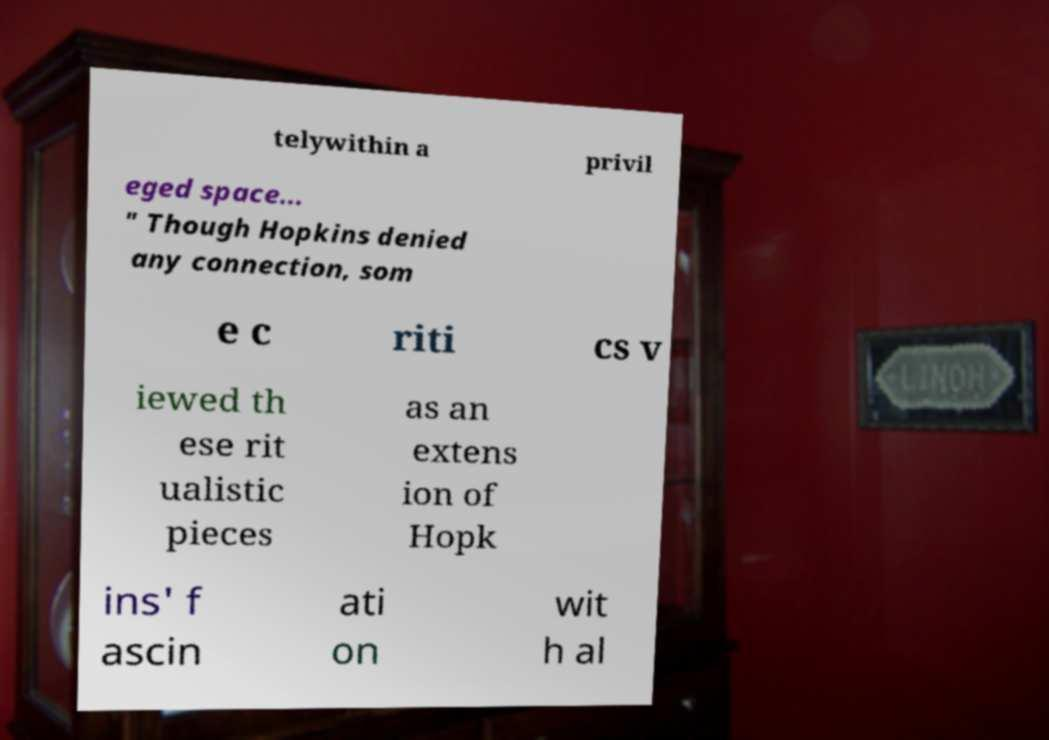Could you extract and type out the text from this image? telywithin a privil eged space... " Though Hopkins denied any connection, som e c riti cs v iewed th ese rit ualistic pieces as an extens ion of Hopk ins' f ascin ati on wit h al 